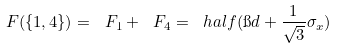Convert formula to latex. <formula><loc_0><loc_0><loc_500><loc_500>\ F ( \{ 1 , 4 \} ) = \ F _ { 1 } + \ F _ { 4 } = \ h a l f ( \i d + \frac { 1 } { \sqrt { 3 } } \sigma _ { x } )</formula> 